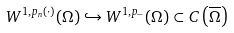<formula> <loc_0><loc_0><loc_500><loc_500>W ^ { 1 , p _ { n } ( \cdot ) } ( \Omega ) \hookrightarrow W ^ { 1 , p _ { - } } ( \Omega ) \subset C \left ( \overline { \Omega } \right )</formula> 